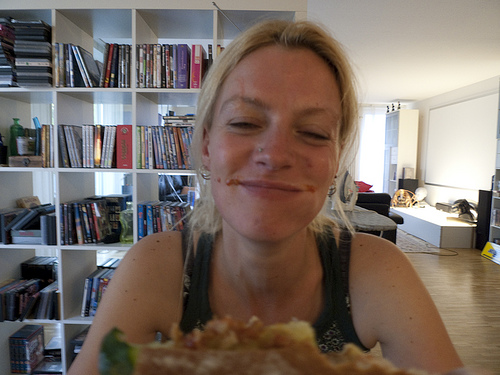<image>
Is the women in front of the pizza? Yes. The women is positioned in front of the pizza, appearing closer to the camera viewpoint. Is there a bookshelf in front of the person? No. The bookshelf is not in front of the person. The spatial positioning shows a different relationship between these objects. 